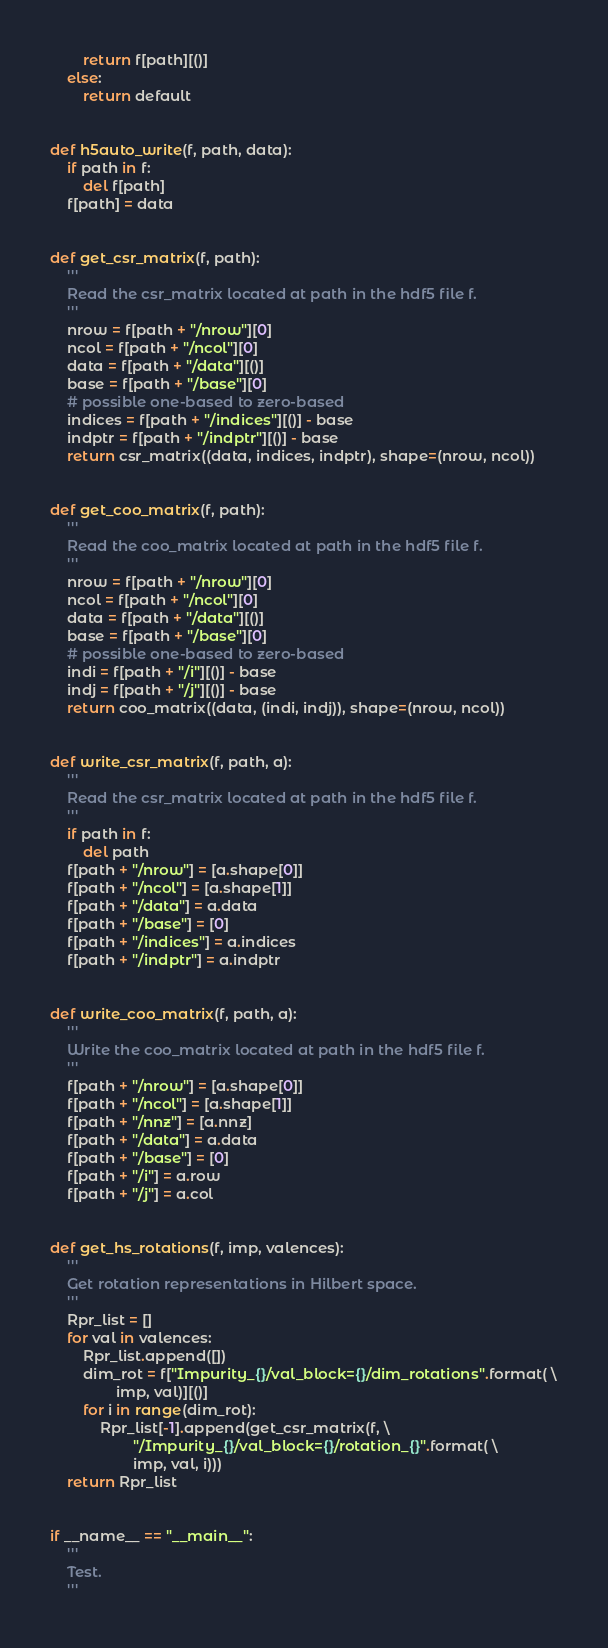<code> <loc_0><loc_0><loc_500><loc_500><_Python_>        return f[path][()]
    else:
        return default


def h5auto_write(f, path, data):
    if path in f:
        del f[path]
    f[path] = data


def get_csr_matrix(f, path):
    '''
    Read the csr_matrix located at path in the hdf5 file f.
    '''
    nrow = f[path + "/nrow"][0]
    ncol = f[path + "/ncol"][0]
    data = f[path + "/data"][()]
    base = f[path + "/base"][0]
    # possible one-based to zero-based
    indices = f[path + "/indices"][()] - base
    indptr = f[path + "/indptr"][()] - base
    return csr_matrix((data, indices, indptr), shape=(nrow, ncol))


def get_coo_matrix(f, path):
    '''
    Read the coo_matrix located at path in the hdf5 file f.
    '''
    nrow = f[path + "/nrow"][0]
    ncol = f[path + "/ncol"][0]
    data = f[path + "/data"][()]
    base = f[path + "/base"][0]
    # possible one-based to zero-based
    indi = f[path + "/i"][()] - base
    indj = f[path + "/j"][()] - base
    return coo_matrix((data, (indi, indj)), shape=(nrow, ncol))


def write_csr_matrix(f, path, a):
    '''
    Read the csr_matrix located at path in the hdf5 file f.
    '''
    if path in f:
        del path
    f[path + "/nrow"] = [a.shape[0]]
    f[path + "/ncol"] = [a.shape[1]]
    f[path + "/data"] = a.data
    f[path + "/base"] = [0]
    f[path + "/indices"] = a.indices
    f[path + "/indptr"] = a.indptr


def write_coo_matrix(f, path, a):
    '''
    Write the coo_matrix located at path in the hdf5 file f.
    '''
    f[path + "/nrow"] = [a.shape[0]]
    f[path + "/ncol"] = [a.shape[1]]
    f[path + "/nnz"] = [a.nnz]
    f[path + "/data"] = a.data
    f[path + "/base"] = [0]
    f[path + "/i"] = a.row
    f[path + "/j"] = a.col


def get_hs_rotations(f, imp, valences):
    '''
    Get rotation representations in Hilbert space.
    '''
    Rpr_list = []
    for val in valences:
        Rpr_list.append([])
        dim_rot = f["Impurity_{}/val_block={}/dim_rotations".format( \
                imp, val)][()]
        for i in range(dim_rot):
            Rpr_list[-1].append(get_csr_matrix(f, \
                    "/Impurity_{}/val_block={}/rotation_{}".format( \
                    imp, val, i)))
    return Rpr_list


if __name__ == "__main__":
    '''
    Test.
    '''
</code> 